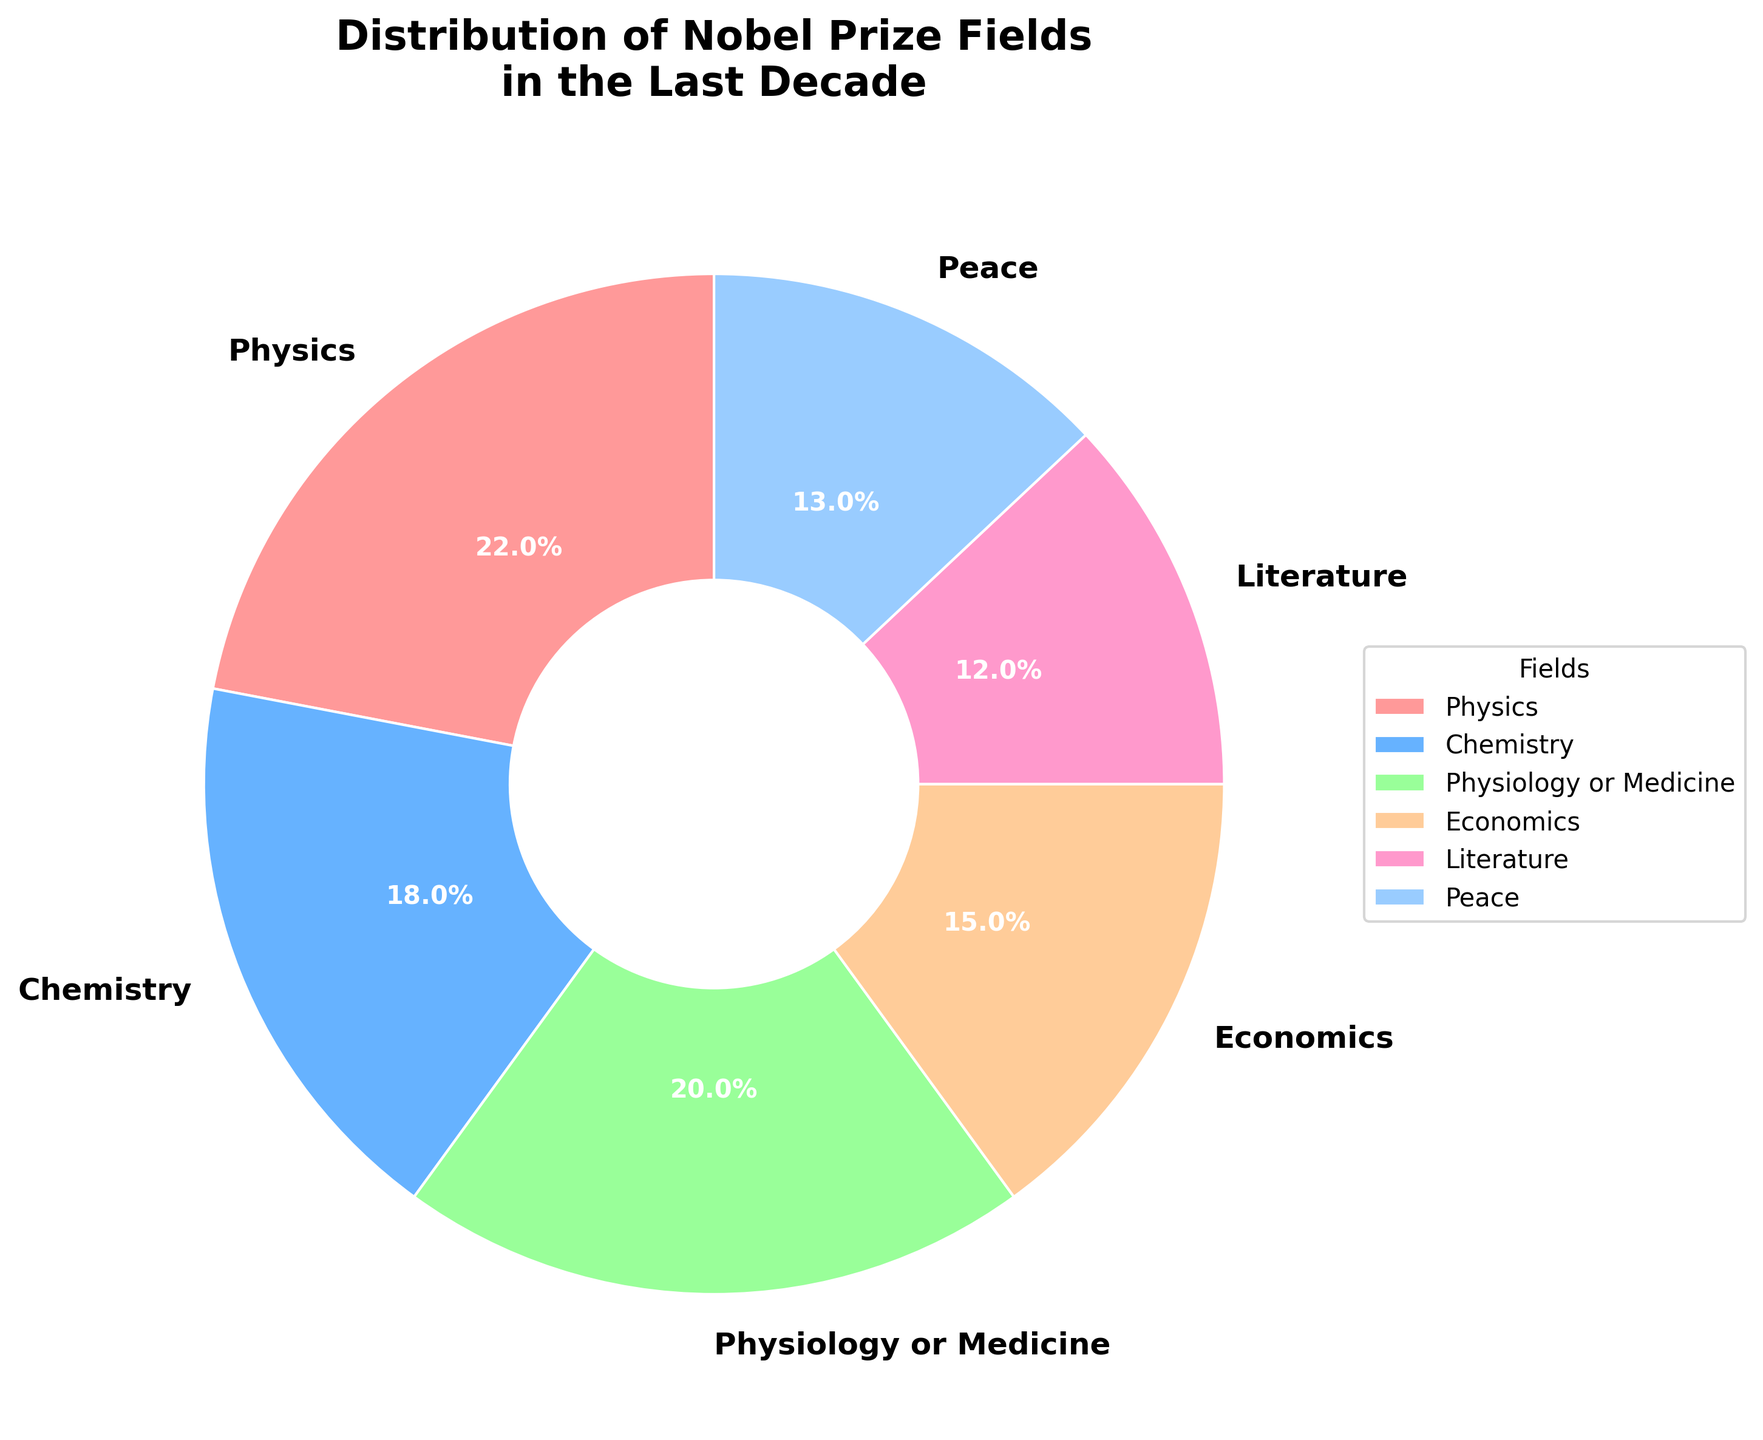Which field has the highest percentage of Nobel Prize winners in the last decade? The pie chart shows the distribution of different fields by percentage. The color slices represent each field. The largest slice corresponds to Physics with 22%.
Answer: Physics Which two fields have the closest percentages of Nobel Prize winners? Looking at the pie chart, Chemistry has 18% and Physiology or Medicine has 20%. These two fields have the closest percentages.
Answer: Chemistry and Physiology or Medicine Is the percentage of Nobel Prize winners in Literature higher or lower than in Peace? By observing the pie chart, Literature has a percentage of 12%, while Peace has 13%. Therefore, Literature is lower than Peace.
Answer: Lower What is the combined percentage of Nobel Prize winners in Physics and Chemistry? Sum the percentages of Physics (22%) and Chemistry (18%). The combined percentage is 22% + 18% = 40%.
Answer: 40% Which fields have less than 20% of Nobel Prize winners? In the pie chart, the fields Economics (15%), Literature (12%), and Peace (13%) all have percentages less than 20%.
Answer: Economics, Literature, Peace What percentage more Nobel Prize winners are there in Physiology or Medicine compared to Economics? Physiology or Medicine has 20% and Economics has 15%. The difference is 20% - 15% = 5%.
Answer: 5% How many fields have a percentage greater than the average percentage of all fields? First, calculate the average percentage: (22 + 18 + 20 + 15 + 12 + 13) / 6 = 16.67%. Fields with more than 16.67% are Physics (22%), Chemistry (18%), and Physiology or Medicine (20%).
Answer: 3 Compare the total percentage of Nobel Prize winners in Physiology or Medicine and Peace. Is it more or less than Chemistry? Sum Physiology or Medicine (20%) and Peace (13%) to get 33%. Compare it to Chemistry, which is 18%. 33% is more than 18%.
Answer: More Which field occupies the blue color in the pie chart? By observing the colors in the pie chart, the blue slice represents Chemistry.
Answer: Chemistry 